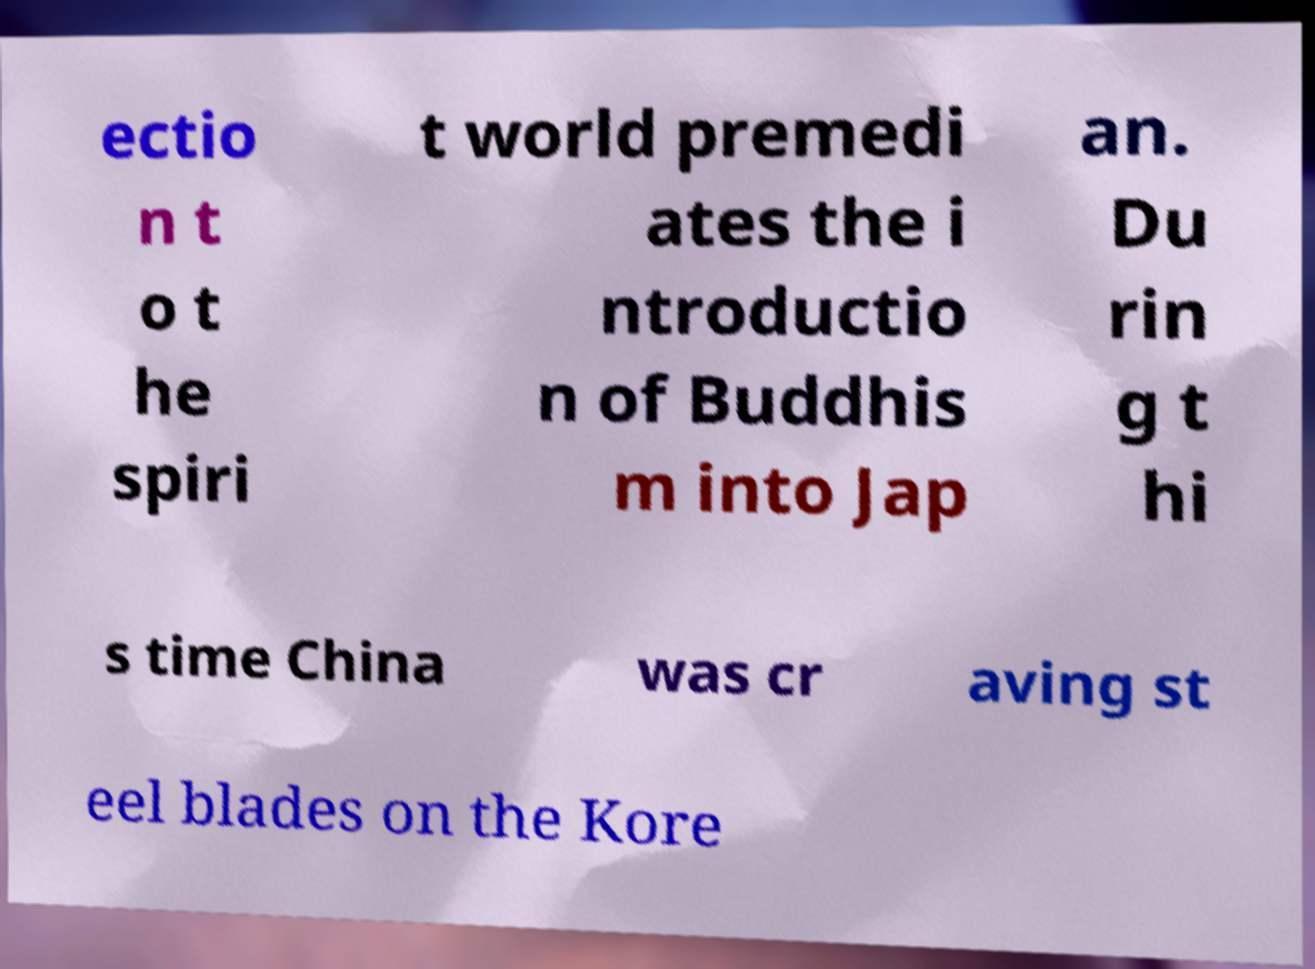Could you extract and type out the text from this image? ectio n t o t he spiri t world premedi ates the i ntroductio n of Buddhis m into Jap an. Du rin g t hi s time China was cr aving st eel blades on the Kore 